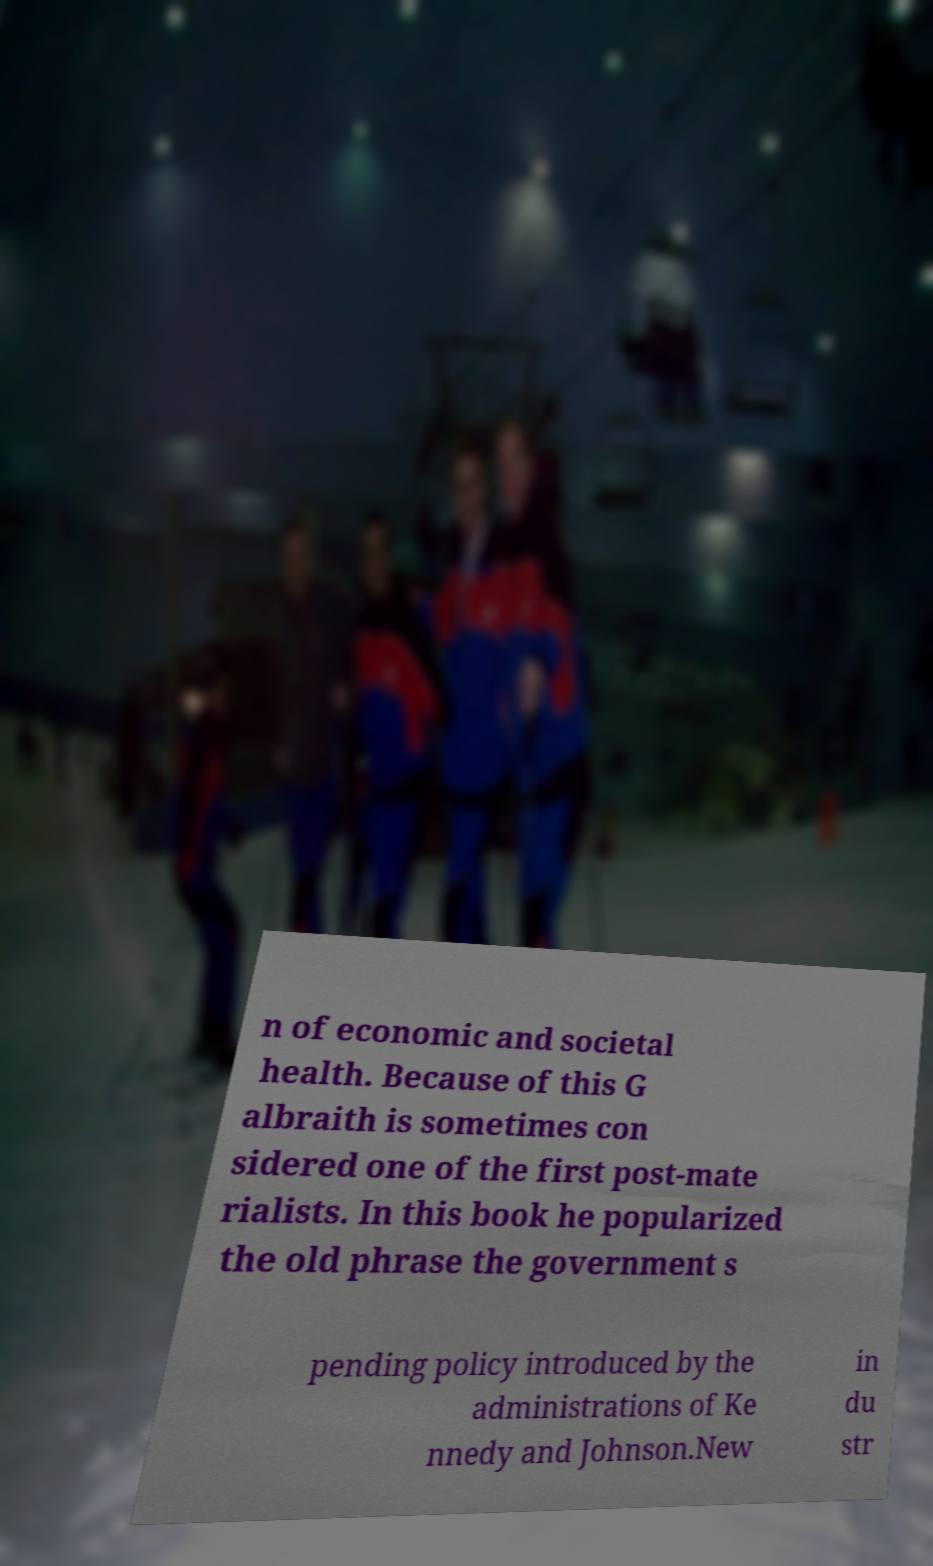Can you read and provide the text displayed in the image?This photo seems to have some interesting text. Can you extract and type it out for me? n of economic and societal health. Because of this G albraith is sometimes con sidered one of the first post-mate rialists. In this book he popularized the old phrase the government s pending policy introduced by the administrations of Ke nnedy and Johnson.New in du str 